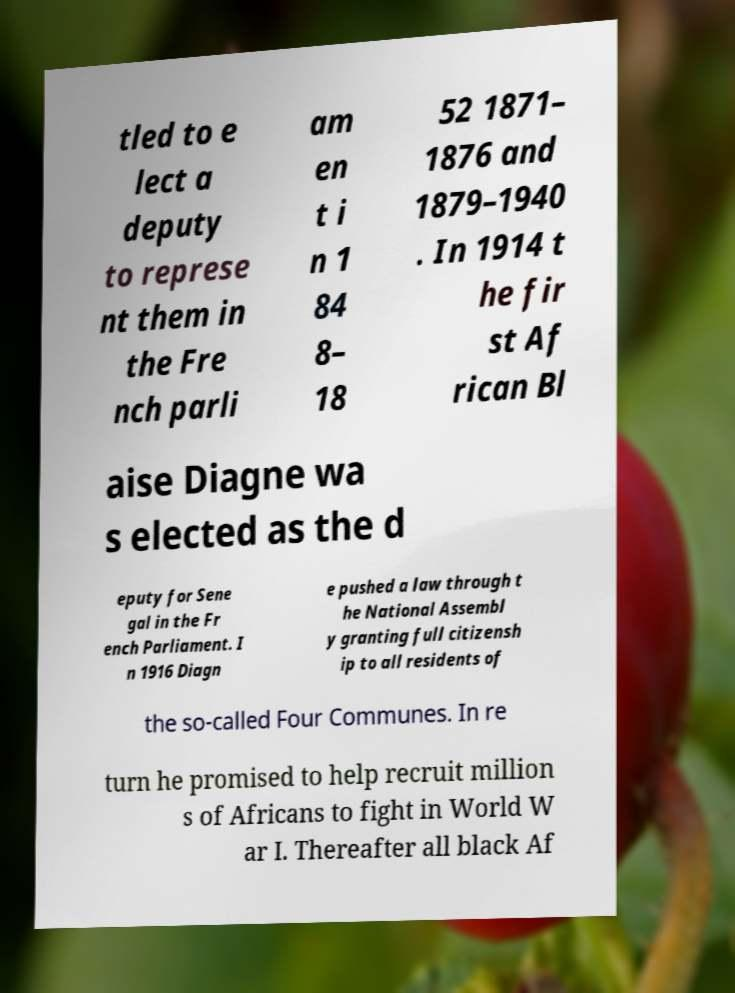Can you accurately transcribe the text from the provided image for me? tled to e lect a deputy to represe nt them in the Fre nch parli am en t i n 1 84 8– 18 52 1871– 1876 and 1879–1940 . In 1914 t he fir st Af rican Bl aise Diagne wa s elected as the d eputy for Sene gal in the Fr ench Parliament. I n 1916 Diagn e pushed a law through t he National Assembl y granting full citizensh ip to all residents of the so-called Four Communes. In re turn he promised to help recruit million s of Africans to fight in World W ar I. Thereafter all black Af 